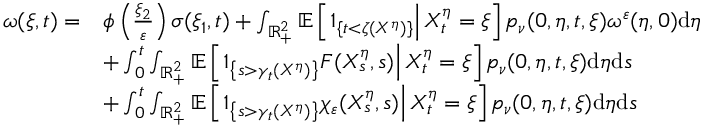Convert formula to latex. <formula><loc_0><loc_0><loc_500><loc_500>\begin{array} { r l } { \omega ( \xi , t ) = } & { \phi \left ( \frac { \xi _ { 2 } } { \varepsilon } \right ) \sigma ( \xi _ { 1 } , t ) + \int _ { \mathbb { R } _ { + } ^ { 2 } } \mathbb { E } \left [ 1 _ { \{ t < \zeta ( X ^ { \eta } ) \} } \right | X _ { t } ^ { \eta } = \xi \right ] p _ { \nu } ( 0 , \eta , t , \xi ) \omega ^ { \varepsilon } ( \eta , 0 ) d \eta } \\ & { + \int _ { 0 } ^ { t } \int _ { \mathbb { R } _ { + } ^ { 2 } } \mathbb { E } \left [ 1 _ { \left \{ s > \gamma _ { t } ( X ^ { \eta } ) \right \} } F ( X _ { s } ^ { \eta } , s ) \right | X _ { t } ^ { \eta } = \xi \right ] p _ { \nu } ( 0 , \eta , t , \xi ) d \eta d s } \\ & { + \int _ { 0 } ^ { t } \int _ { \mathbb { R } _ { + } ^ { 2 } } \mathbb { E } \left [ 1 _ { \left \{ s > \gamma _ { t } ( X ^ { \eta } ) \right \} } \chi _ { \varepsilon } ( X _ { s } ^ { \eta } , s ) \right | X _ { t } ^ { \eta } = \xi \right ] p _ { \nu } ( 0 , \eta , t , \xi ) d \eta d s } \end{array}</formula> 